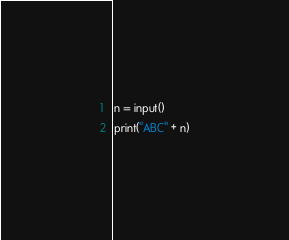Convert code to text. <code><loc_0><loc_0><loc_500><loc_500><_Python_>n = input()
print("ABC" + n)
</code> 